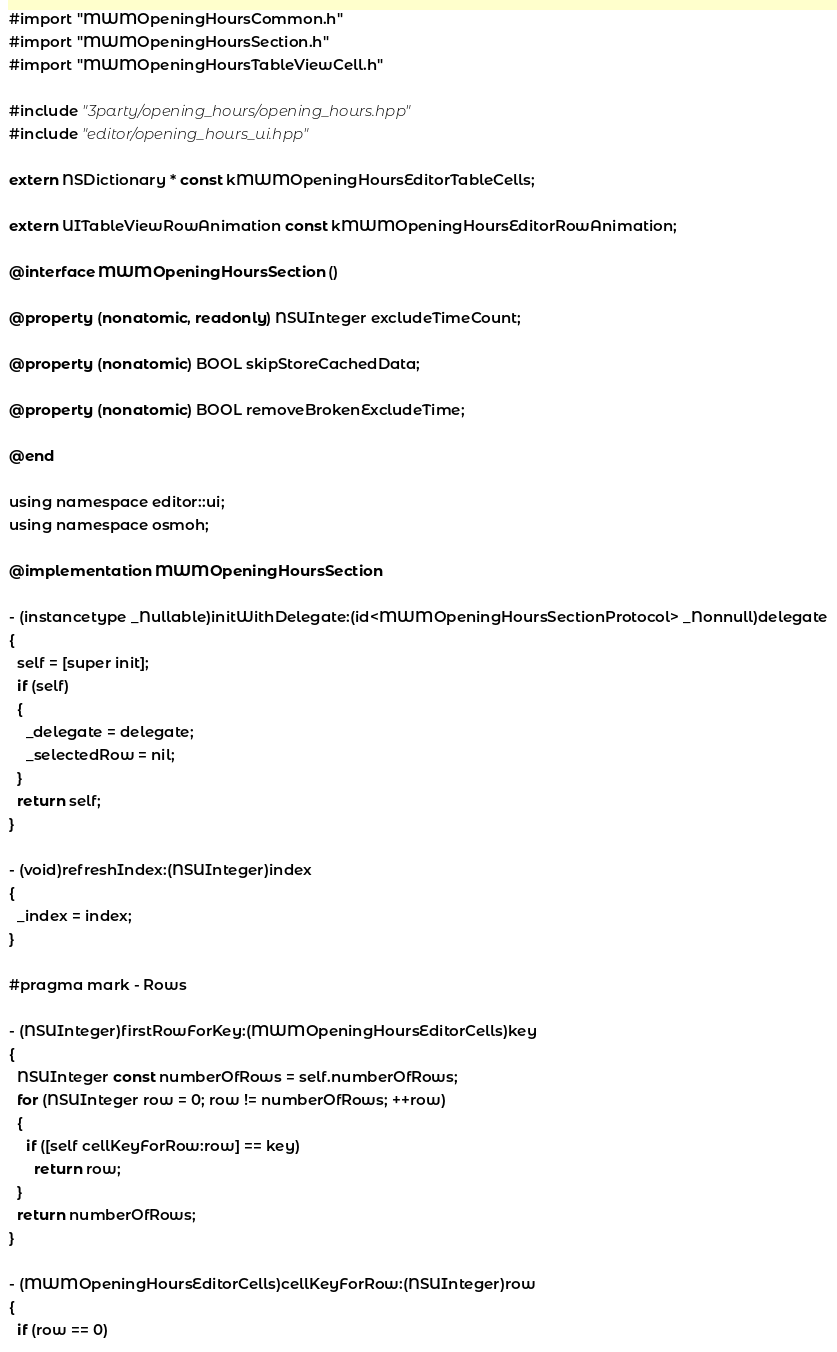<code> <loc_0><loc_0><loc_500><loc_500><_ObjectiveC_>#import "MWMOpeningHoursCommon.h"
#import "MWMOpeningHoursSection.h"
#import "MWMOpeningHoursTableViewCell.h"

#include "3party/opening_hours/opening_hours.hpp"
#include "editor/opening_hours_ui.hpp"

extern NSDictionary * const kMWMOpeningHoursEditorTableCells;

extern UITableViewRowAnimation const kMWMOpeningHoursEditorRowAnimation;

@interface MWMOpeningHoursSection ()

@property (nonatomic, readonly) NSUInteger excludeTimeCount;

@property (nonatomic) BOOL skipStoreCachedData;

@property (nonatomic) BOOL removeBrokenExcludeTime;

@end

using namespace editor::ui;
using namespace osmoh;

@implementation MWMOpeningHoursSection

- (instancetype _Nullable)initWithDelegate:(id<MWMOpeningHoursSectionProtocol> _Nonnull)delegate
{
  self = [super init];
  if (self)
  {
    _delegate = delegate;
    _selectedRow = nil;
  }
  return self;
}

- (void)refreshIndex:(NSUInteger)index
{
  _index = index;
}

#pragma mark - Rows

- (NSUInteger)firstRowForKey:(MWMOpeningHoursEditorCells)key
{
  NSUInteger const numberOfRows = self.numberOfRows;
  for (NSUInteger row = 0; row != numberOfRows; ++row)
  {
    if ([self cellKeyForRow:row] == key)
      return row;
  }
  return numberOfRows;
}

- (MWMOpeningHoursEditorCells)cellKeyForRow:(NSUInteger)row
{
  if (row == 0)</code> 